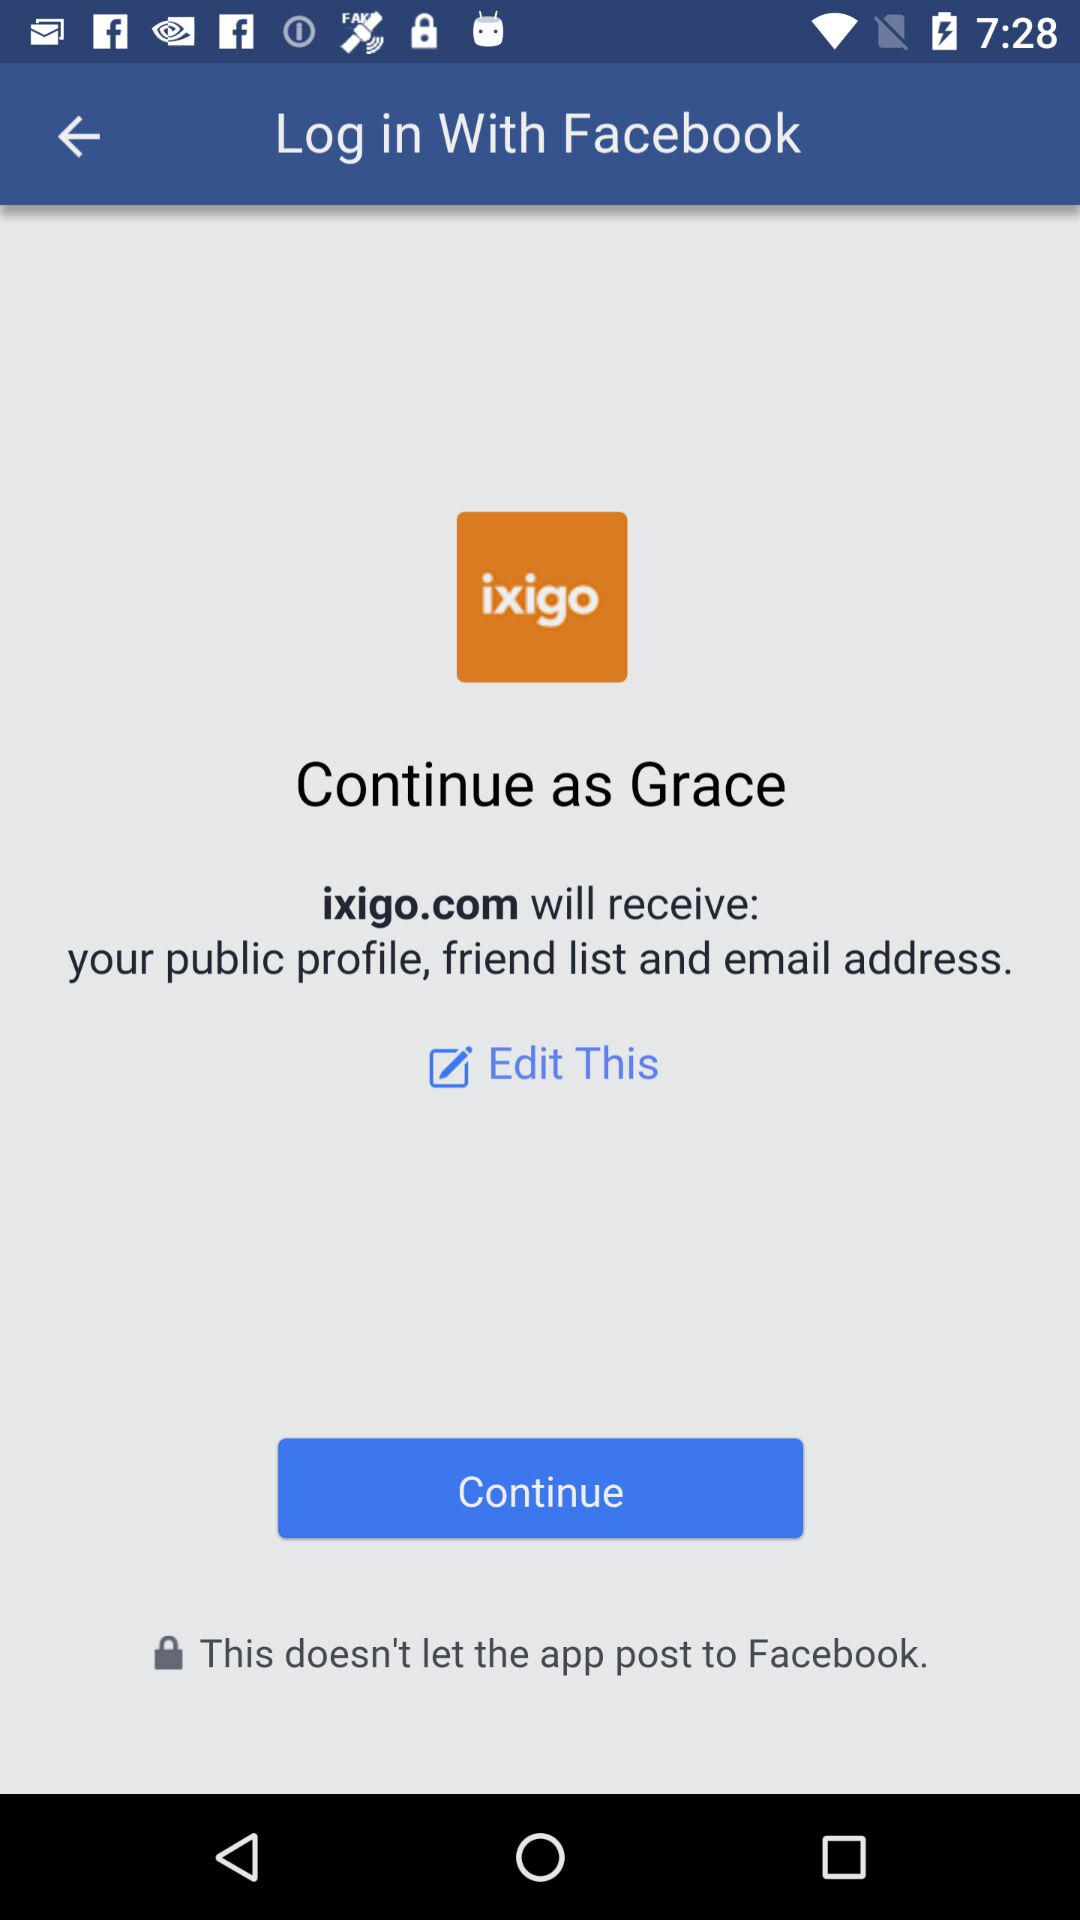What application is asking for permission? The application is "ixigo.com". 